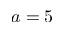<formula> <loc_0><loc_0><loc_500><loc_500>a = 5</formula> 